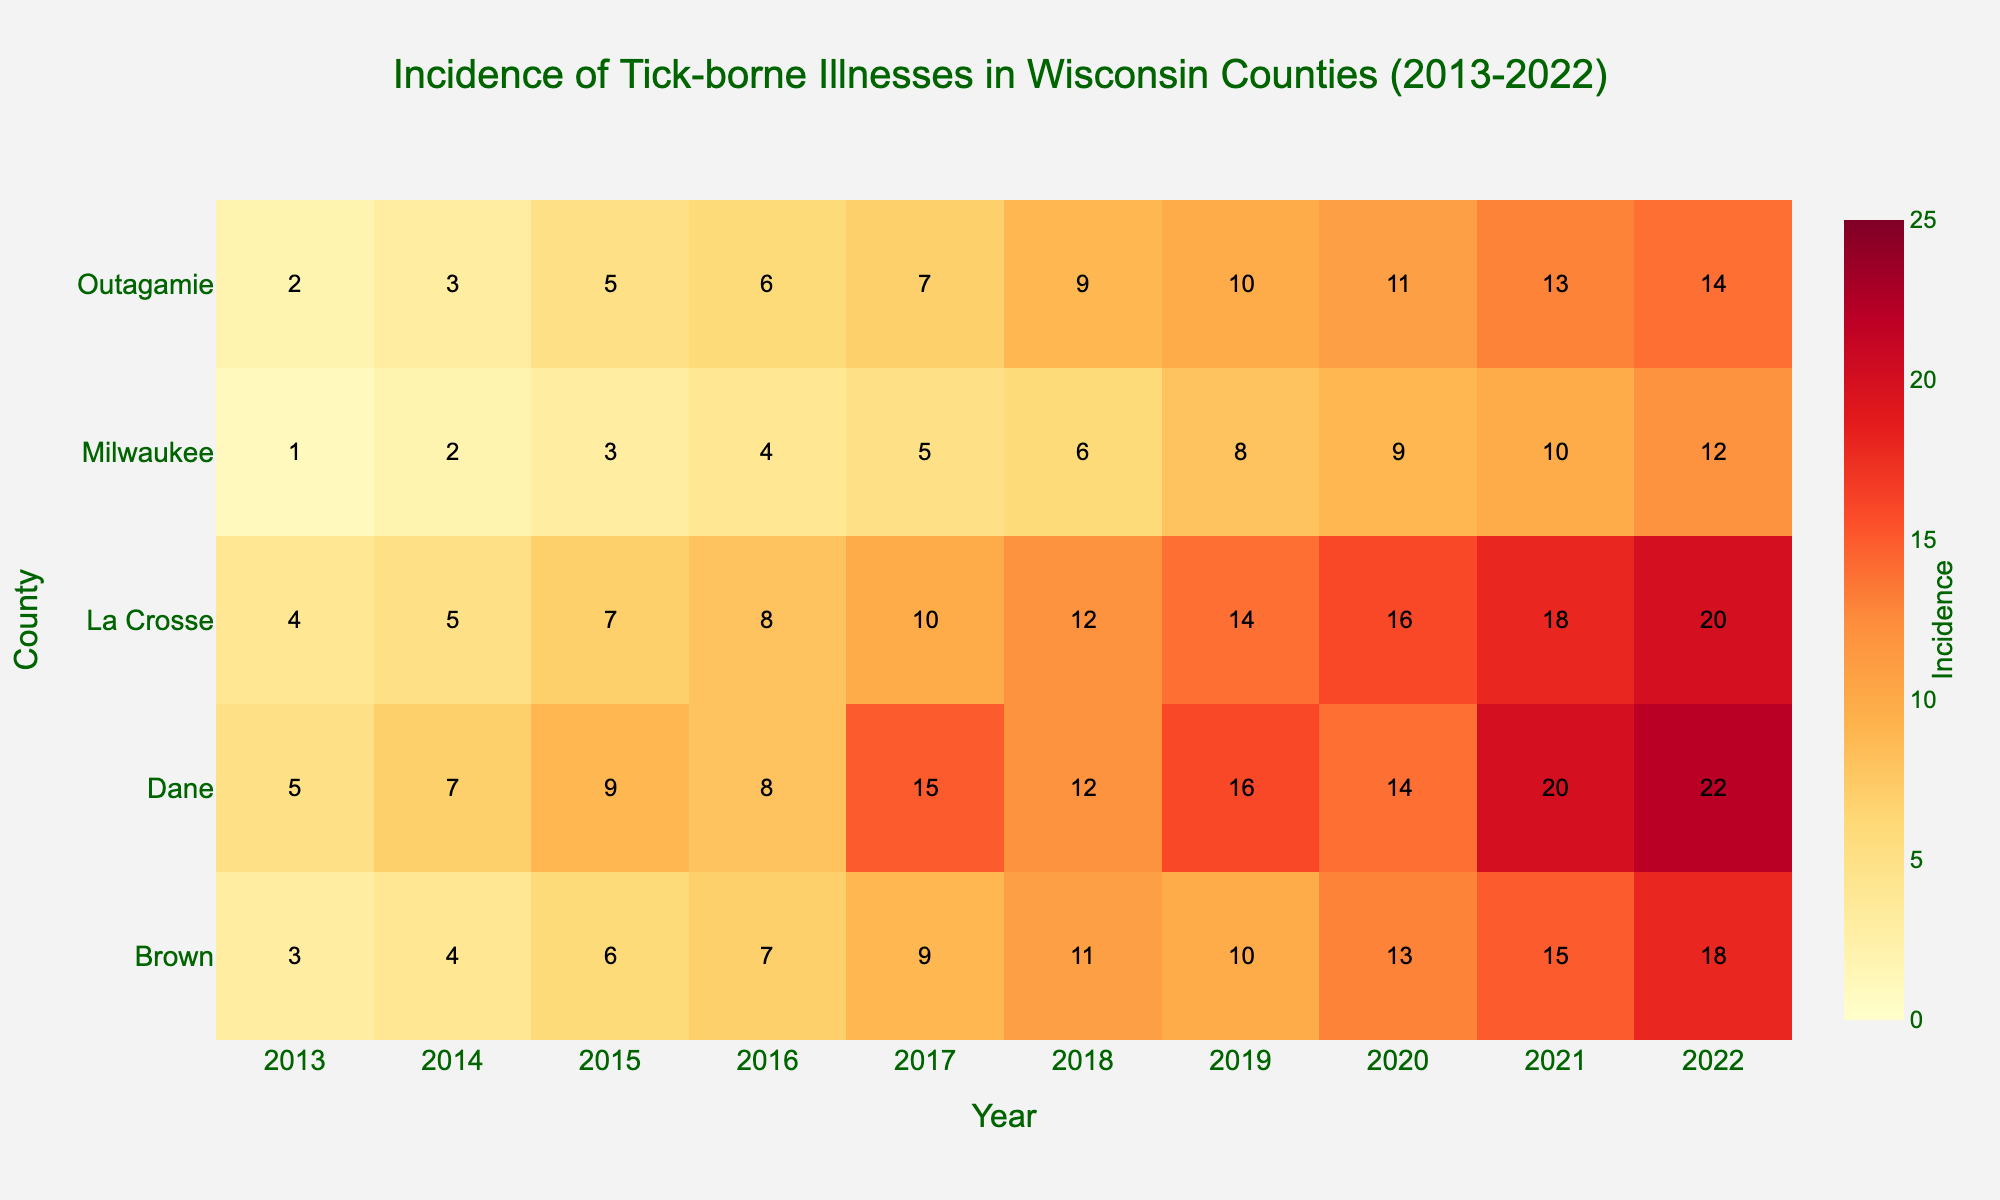What's the title of the heatmap? The title of the heatmap is displayed at the top of the figure and describes what the heatmap is about. The title provides context for the data being visualized.
Answer: Incidence of Tick-borne Illnesses in Wisconsin Counties (2013-2022) What are the x-axis and y-axis labels? The x-axis label indicates the range of years from 2013 to 2022, while the y-axis label lists various counties in Wisconsin. These labels help identify the variables represented in the heatmap.
Answer: Year, County Which county had the highest incidence of tick-borne illnesses in 2022? To answer this, locate the column for 2022 on the x-axis and find the highest value in that column. The corresponding row on the y-axis will give the county name.
Answer: Dane County How has the incidence of tick-borne illnesses in Milwaukee County changed from 2013 to 2022? Track the row for Milwaukee County across all the years from 2013 to 2022. Observe the values to understand the trend in the incidence rate over this period.
Answer: Increased Between which years did Dane County see the most significant increase in incidence? Observe the changes in incidence values for Dane County from year to year and identify the interval where the increase is the greatest.
Answer: 2016 to 2017 What color on the heatmap represents the highest incidence of tick-borne illnesses? Identify the color used for the highest value on the color scale (22 in Dane County in 2022). This color will be at the extreme end of the defined color range.
Answer: Dark red Are there any counties where the incidence did not increase over the decade? Examine the trend for each county from 2013 to 2022. Look for any county where the values either decrease or remain the same over the years.
Answer: No, all counties showed an increase Which county had the lowest overall incidence rates during the decade? For each county, calculate the sum of incidence rates from 2013 to 2022. The county with the smallest sum has the lowest overall incidence rates.
Answer: Milwaukee County 